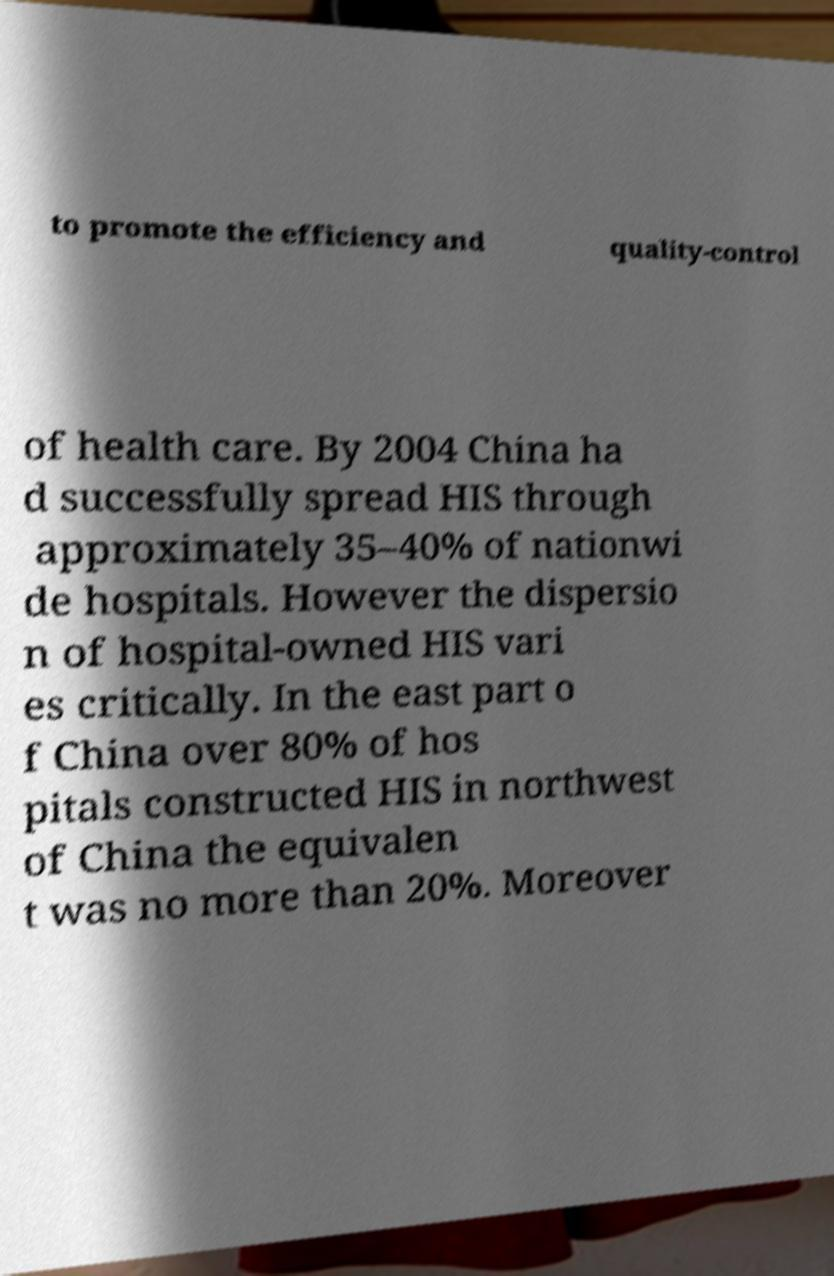For documentation purposes, I need the text within this image transcribed. Could you provide that? to promote the efficiency and quality-control of health care. By 2004 China ha d successfully spread HIS through approximately 35–40% of nationwi de hospitals. However the dispersio n of hospital-owned HIS vari es critically. In the east part o f China over 80% of hos pitals constructed HIS in northwest of China the equivalen t was no more than 20%. Moreover 